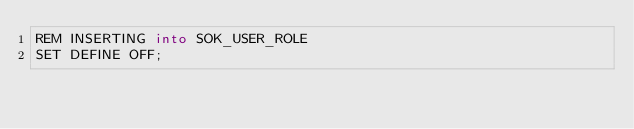<code> <loc_0><loc_0><loc_500><loc_500><_SQL_>REM INSERTING into SOK_USER_ROLE
SET DEFINE OFF;
</code> 